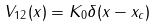<formula> <loc_0><loc_0><loc_500><loc_500>V _ { 1 2 } ( x ) = K _ { 0 } \delta ( x - x _ { c } )</formula> 